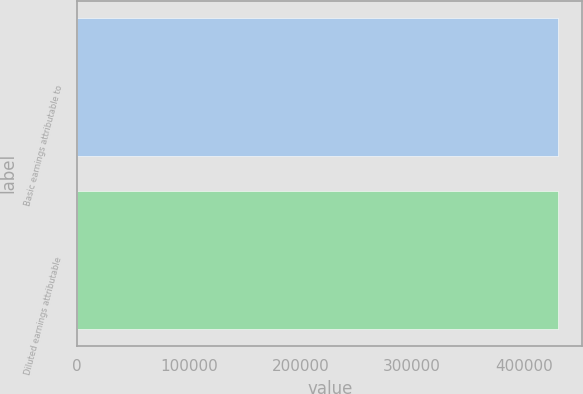Convert chart. <chart><loc_0><loc_0><loc_500><loc_500><bar_chart><fcel>Basic earnings attributable to<fcel>Diluted earnings attributable<nl><fcel>430807<fcel>430807<nl></chart> 